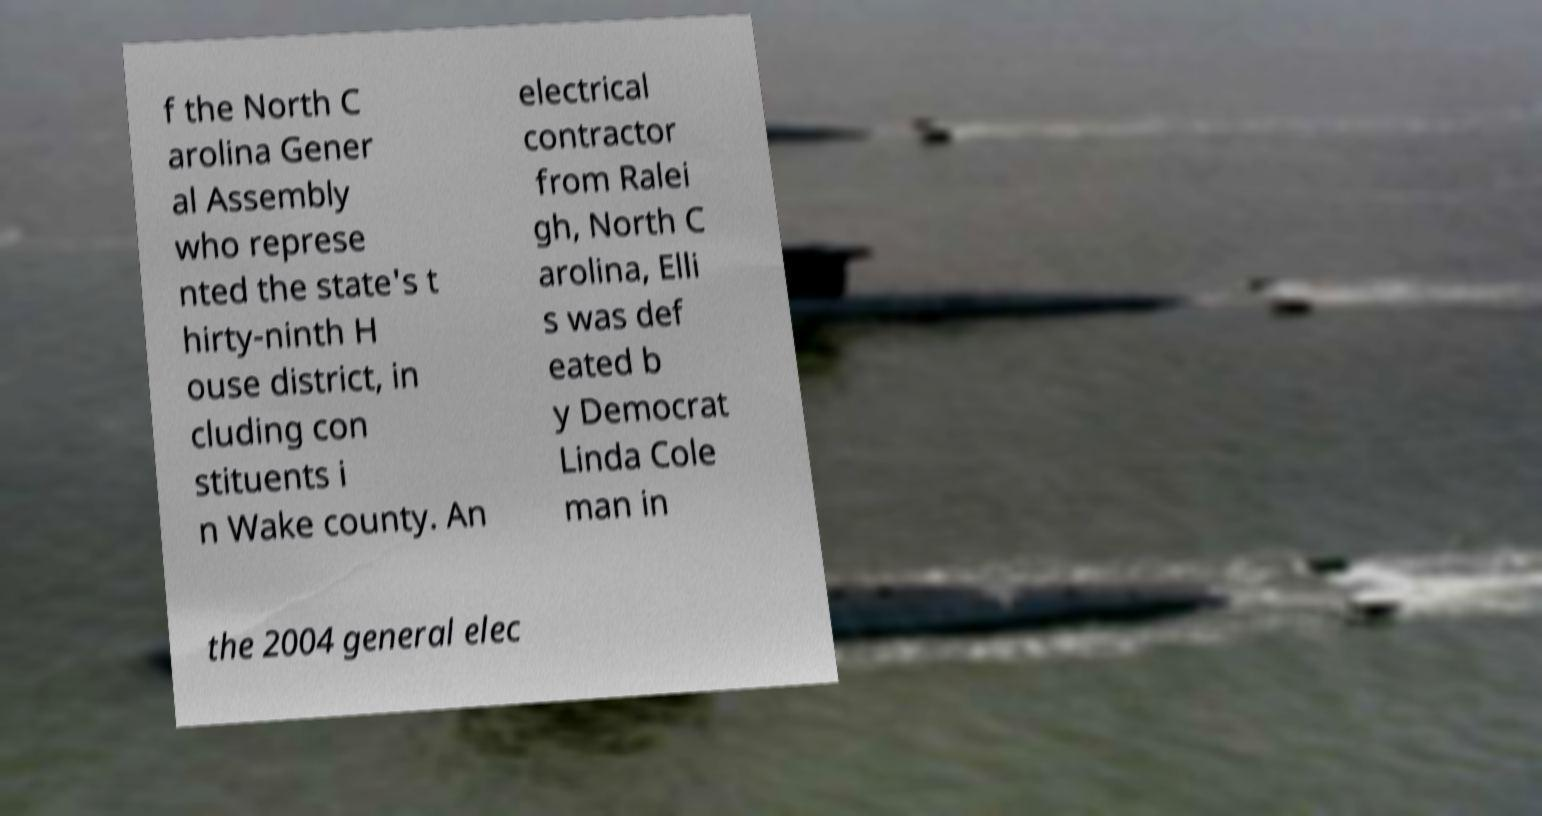Please read and relay the text visible in this image. What does it say? f the North C arolina Gener al Assembly who represe nted the state's t hirty-ninth H ouse district, in cluding con stituents i n Wake county. An electrical contractor from Ralei gh, North C arolina, Elli s was def eated b y Democrat Linda Cole man in the 2004 general elec 